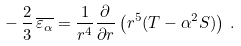Convert formula to latex. <formula><loc_0><loc_0><loc_500><loc_500>- \, \frac { 2 } { 3 } \, \overline { \varepsilon _ { \alpha } } = \frac { 1 } { r ^ { 4 } } \frac { \partial } { \partial r } \left ( r ^ { 5 } ( T - \alpha ^ { 2 } S ) \right ) \, .</formula> 